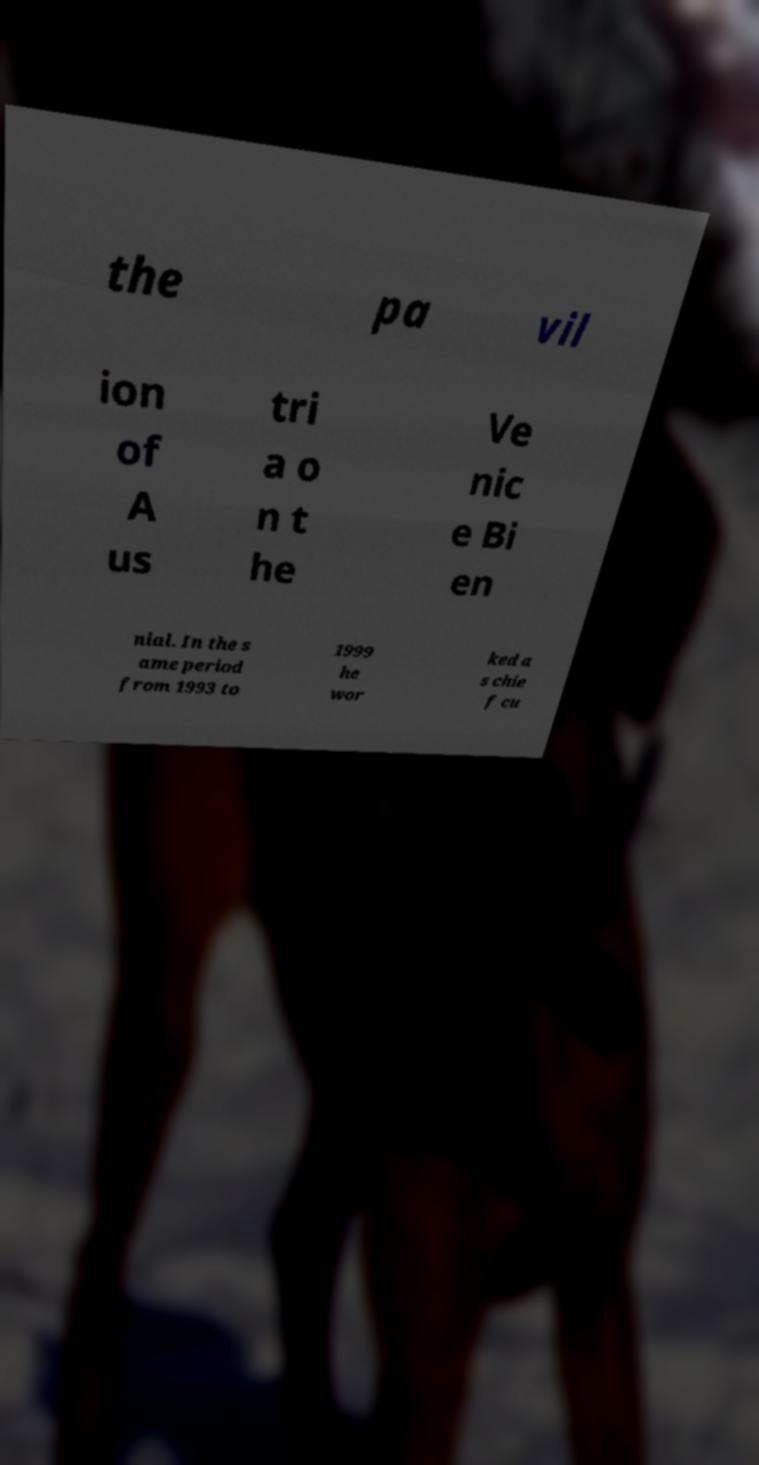Could you assist in decoding the text presented in this image and type it out clearly? the pa vil ion of A us tri a o n t he Ve nic e Bi en nial. In the s ame period from 1993 to 1999 he wor ked a s chie f cu 